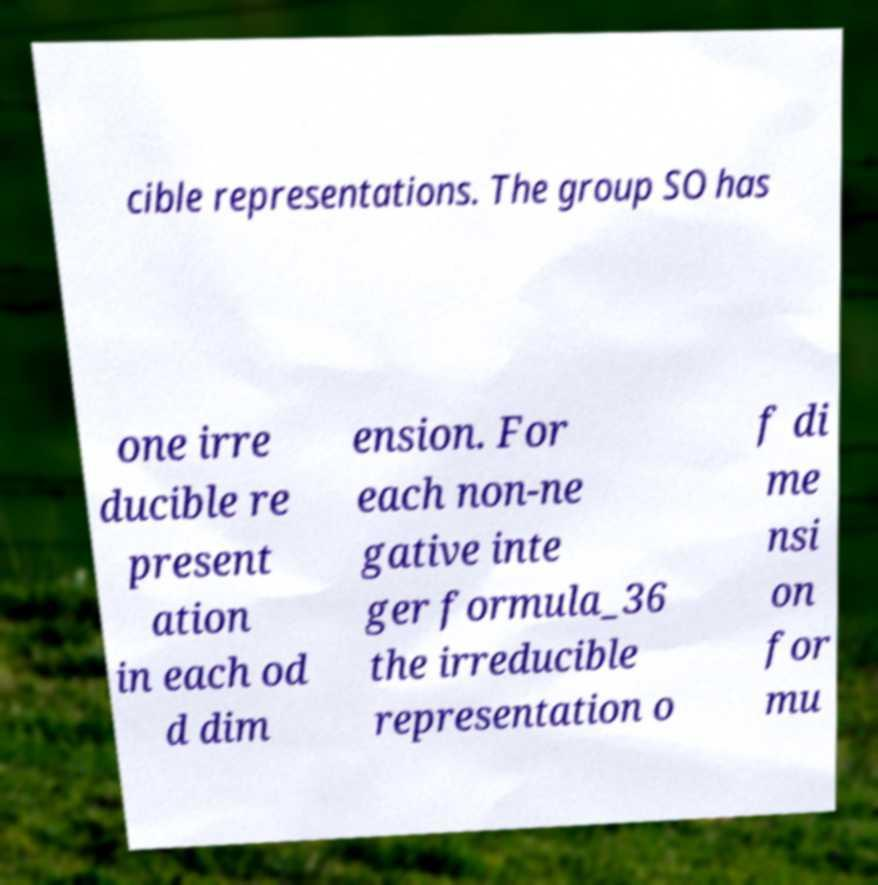I need the written content from this picture converted into text. Can you do that? cible representations. The group SO has one irre ducible re present ation in each od d dim ension. For each non-ne gative inte ger formula_36 the irreducible representation o f di me nsi on for mu 